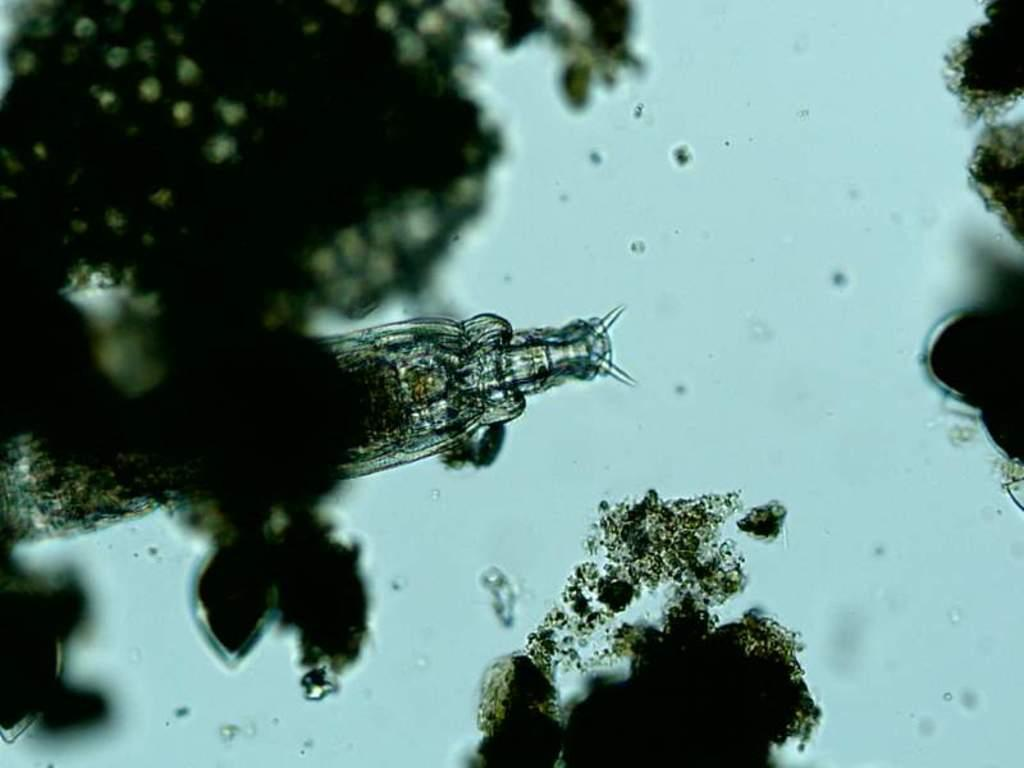What type of creature can be seen in the image? There is an insect in the image. What type of growth is also visible in the image? There is fungus in the image. Where are the insect and fungus located? Both the insect and fungus are on the water. What type of balls can be seen floating near the insect in the image? There are no balls present in the image; it features an insect and fungus on the water. 